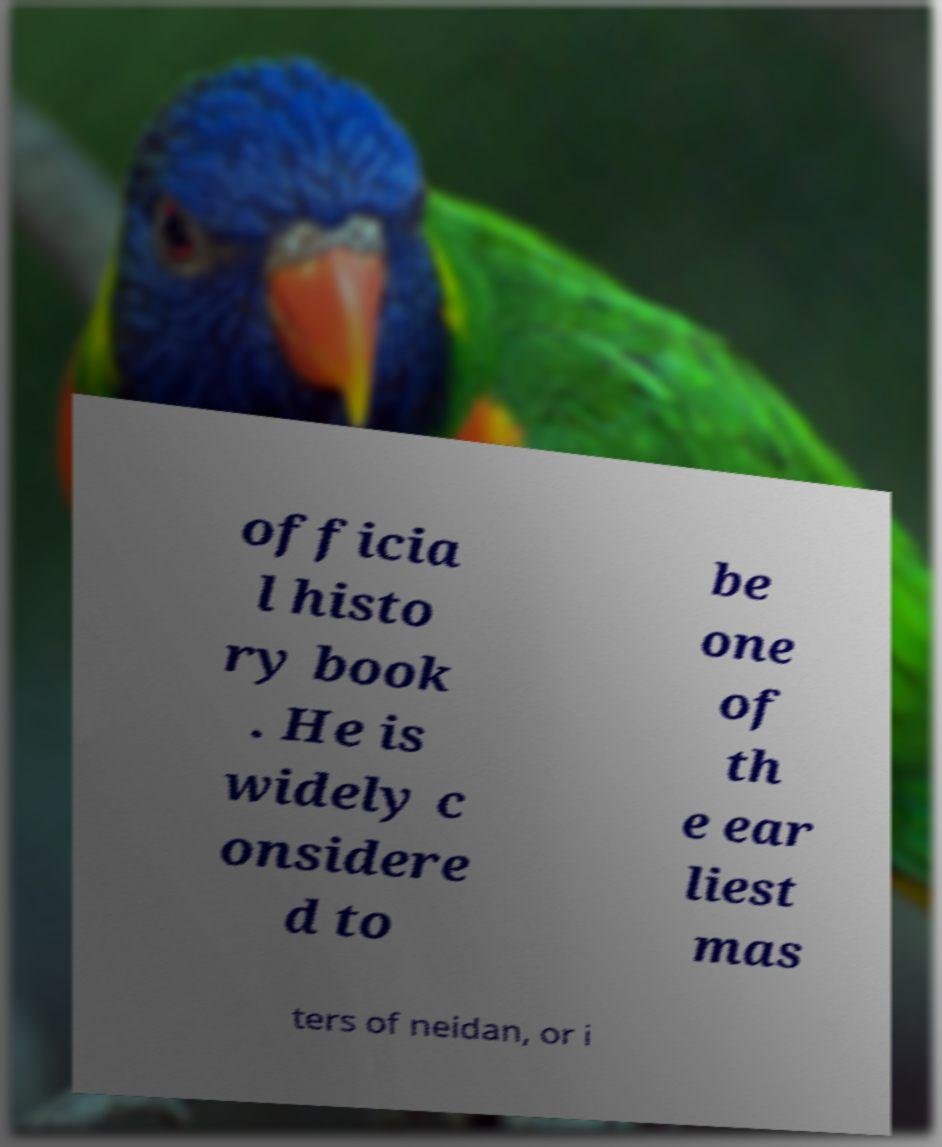Could you extract and type out the text from this image? officia l histo ry book . He is widely c onsidere d to be one of th e ear liest mas ters of neidan, or i 